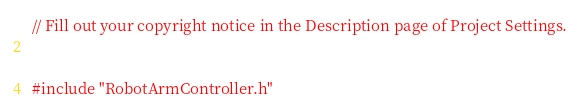<code> <loc_0><loc_0><loc_500><loc_500><_C++_>// Fill out your copyright notice in the Description page of Project Settings.


#include "RobotArmController.h"

</code> 